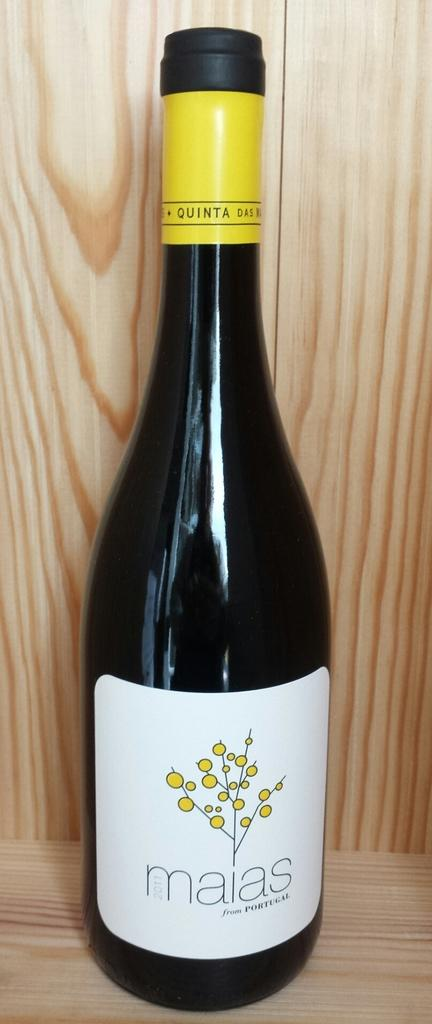<image>
Relay a brief, clear account of the picture shown. A single bottle of Maias wine in front of a wooden wall. 